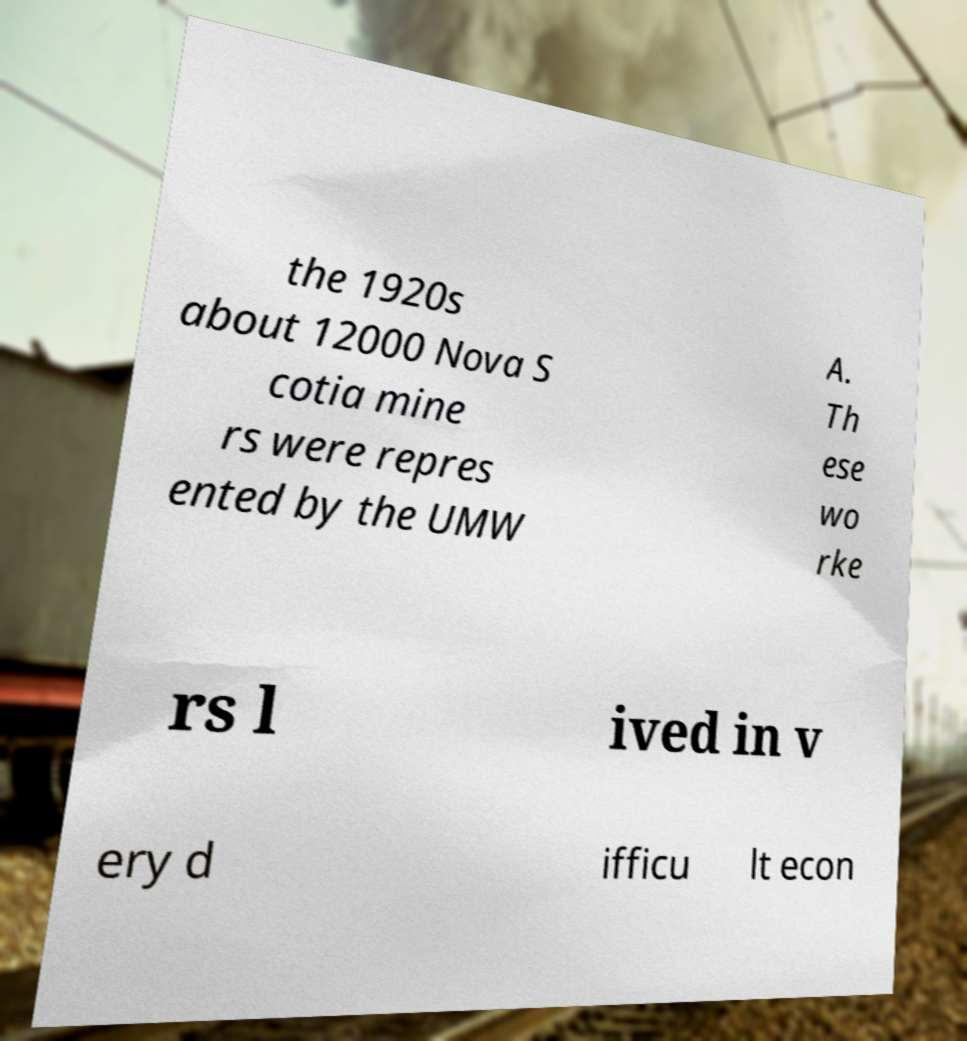Please identify and transcribe the text found in this image. the 1920s about 12000 Nova S cotia mine rs were repres ented by the UMW A. Th ese wo rke rs l ived in v ery d ifficu lt econ 